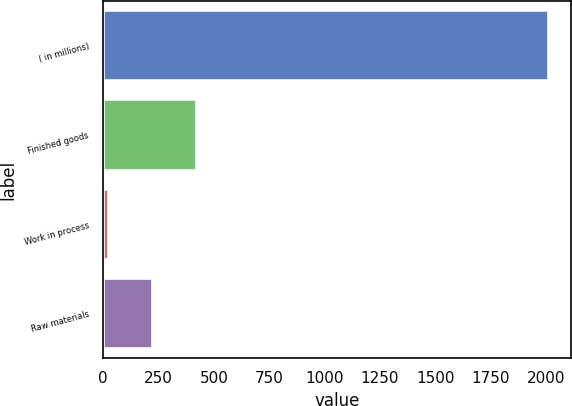Convert chart to OTSL. <chart><loc_0><loc_0><loc_500><loc_500><bar_chart><fcel>( in millions)<fcel>Finished goods<fcel>Work in process<fcel>Raw materials<nl><fcel>2013<fcel>422.44<fcel>24.8<fcel>223.62<nl></chart> 